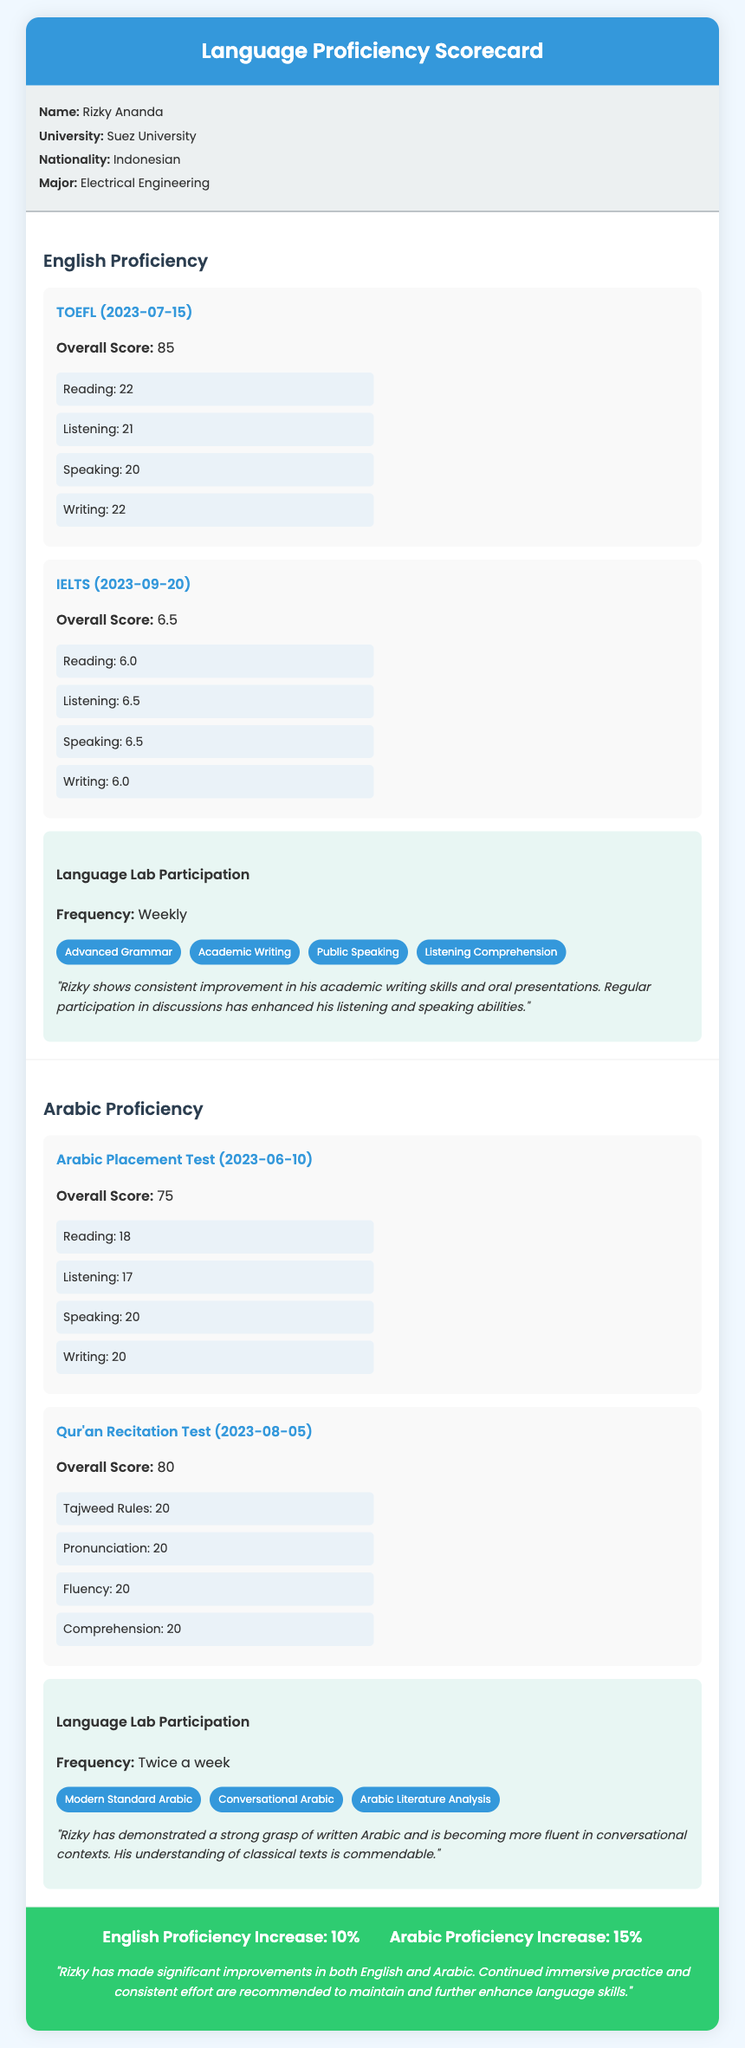what is Rizky's nationality? Rizky's nationality is mentioned in the profile section of the document.
Answer: Indonesian what is the overall score for the TOEFL assessment? The TOEFL overall score is found in the English proficiency section under the assessment for TOEFL.
Answer: 85 what is the frequency of Arabic language lab participation? The frequency of participation can be found in the Arabic proficiency section.
Answer: Twice a week what is the overall score for the IELTS assessment? The overall score for the IELTS assessment is listed under the English proficiency section.
Answer: 6.5 which language had a higher proficiency increase? This can be deduced from the overall progress section, where the increases for both languages are compared.
Answer: Arabic Proficiency Increase how many components are listed for the Arabic Placement Test? The number of components for the Arabic Placement Test is detailed in the assessment section for that test.
Answer: 4 what is the score for Speaking in the IELTS assessment? The score for Speaking is mentioned within the IELTS assessment details.
Answer: 6.5 what modules are included in the English language lab participation? The specific modules are enumerated in the language lab participation section of the English proficiency part.
Answer: Advanced Grammar, Academic Writing, Public Speaking, Listening Comprehension what is the overall score for the Qur'an Recitation Test? The overall score can be found in the assessment section for the Qur'an Recitation Test in Arabic proficiency.
Answer: 80 